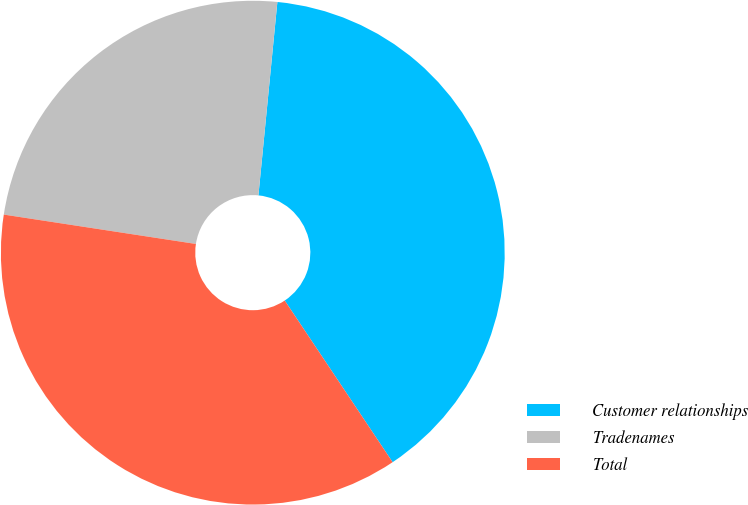Convert chart. <chart><loc_0><loc_0><loc_500><loc_500><pie_chart><fcel>Customer relationships<fcel>Tradenames<fcel>Total<nl><fcel>39.08%<fcel>24.14%<fcel>36.78%<nl></chart> 